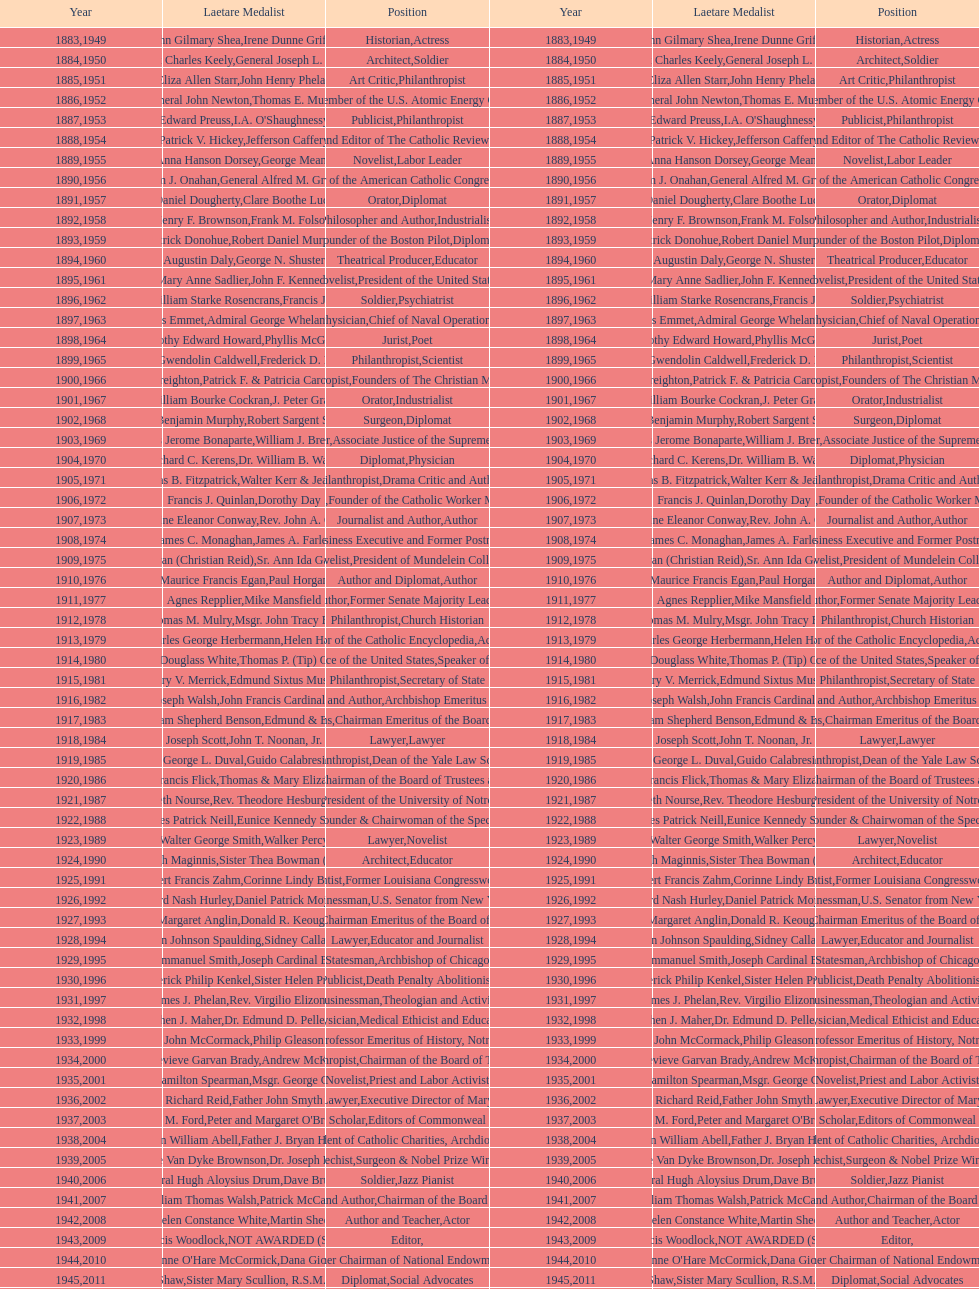Can you name someone who has received this medal in addition to the nobel prize? Dr. Joseph E. Murray. 